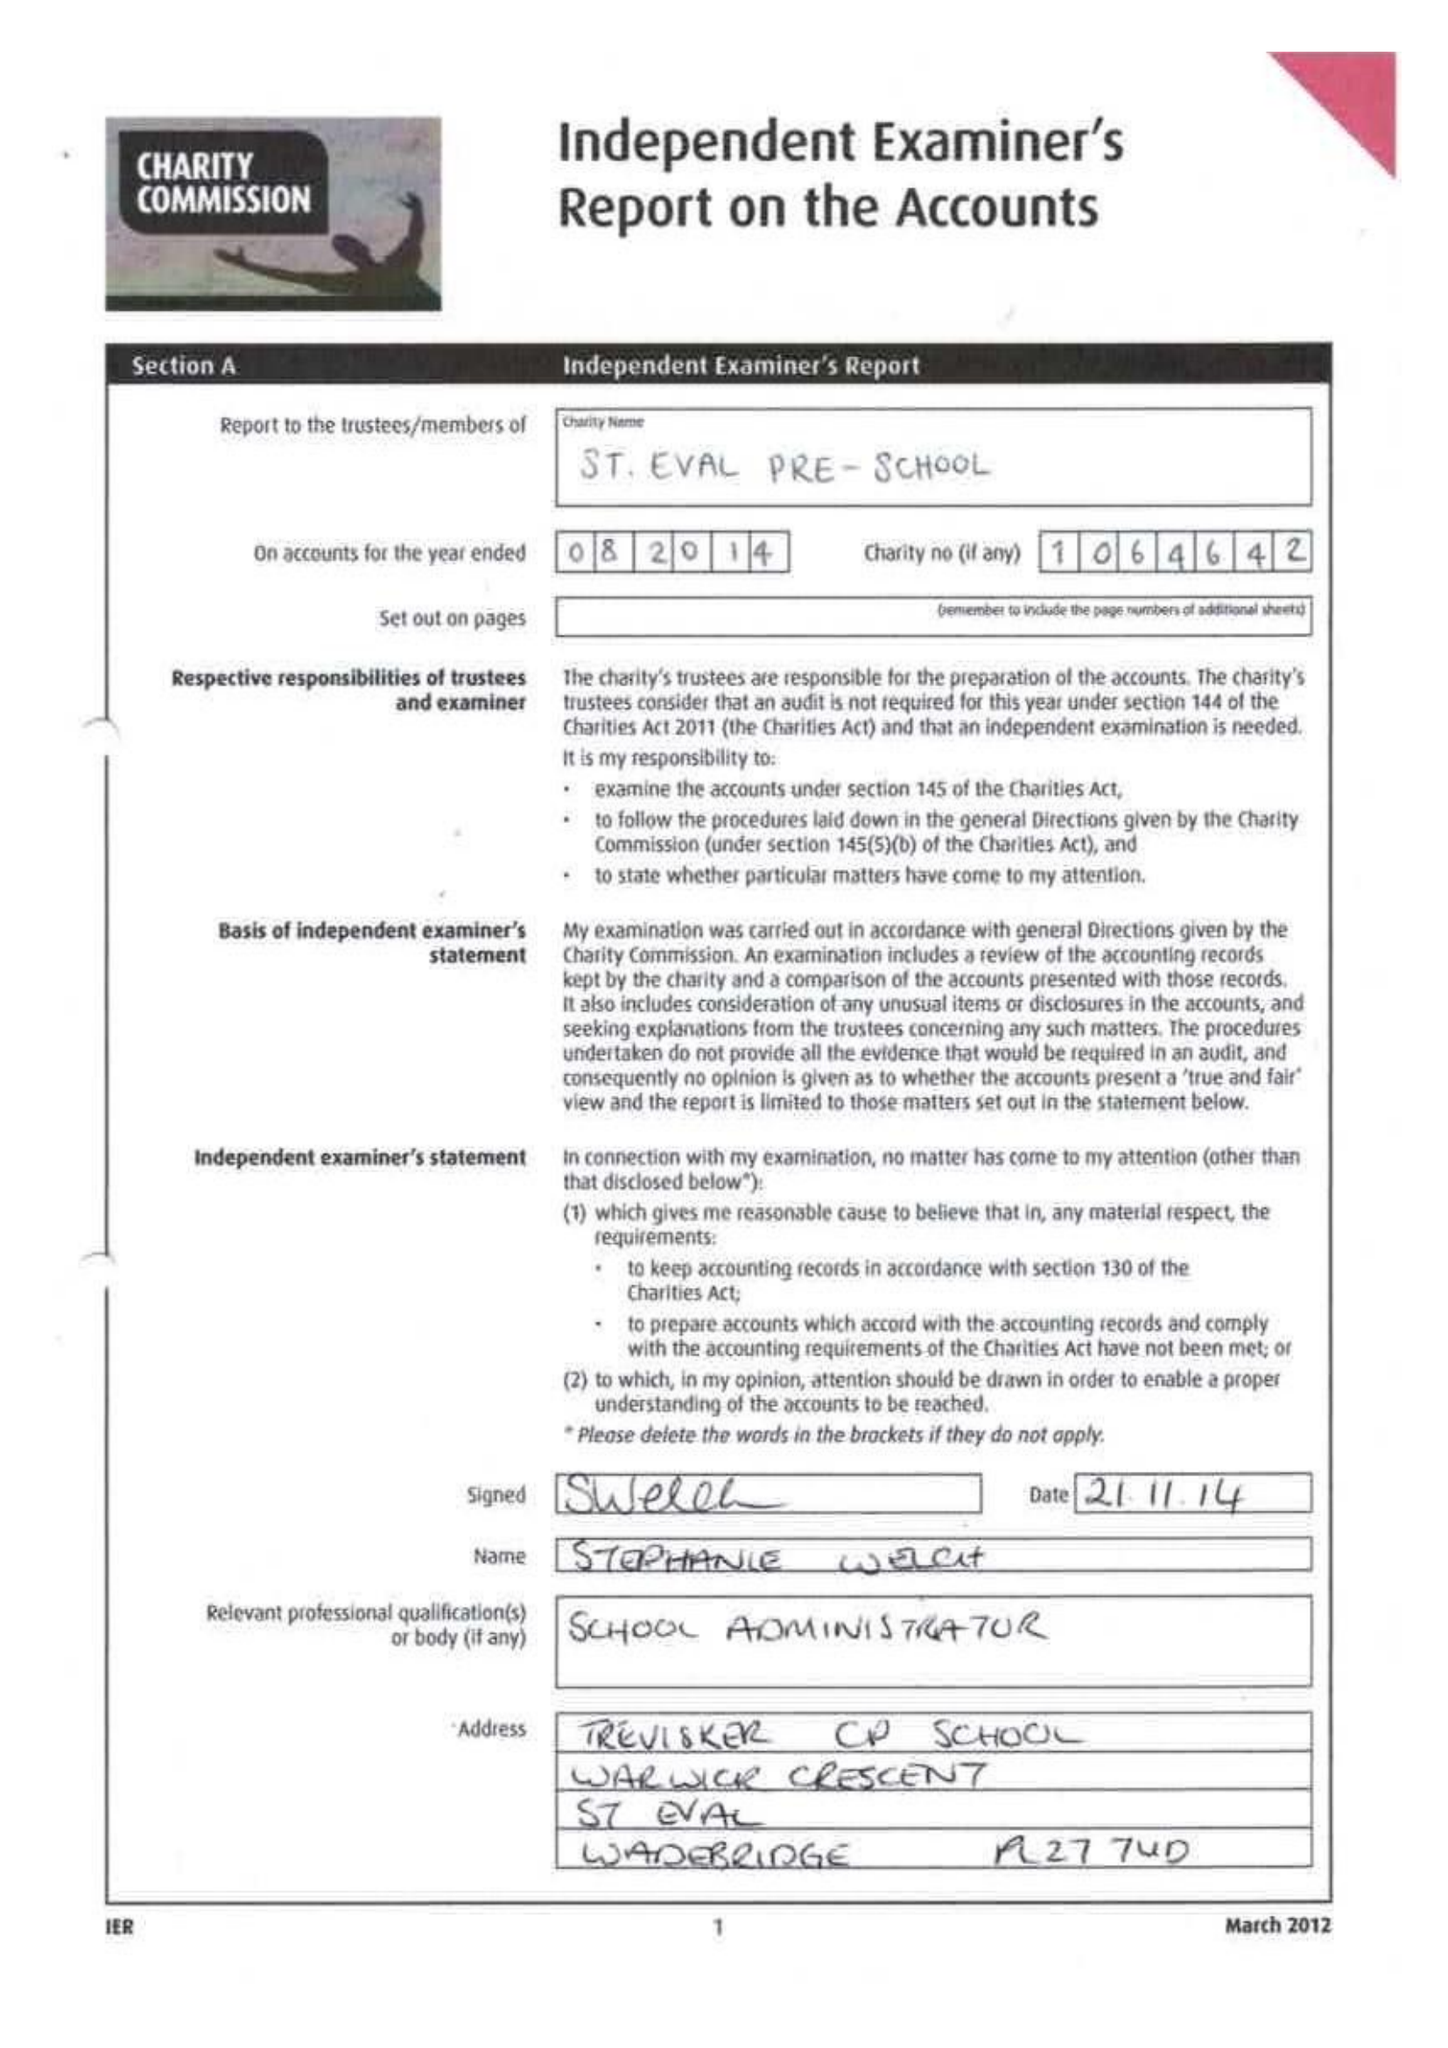What is the value for the spending_annually_in_british_pounds?
Answer the question using a single word or phrase. 89338.00 